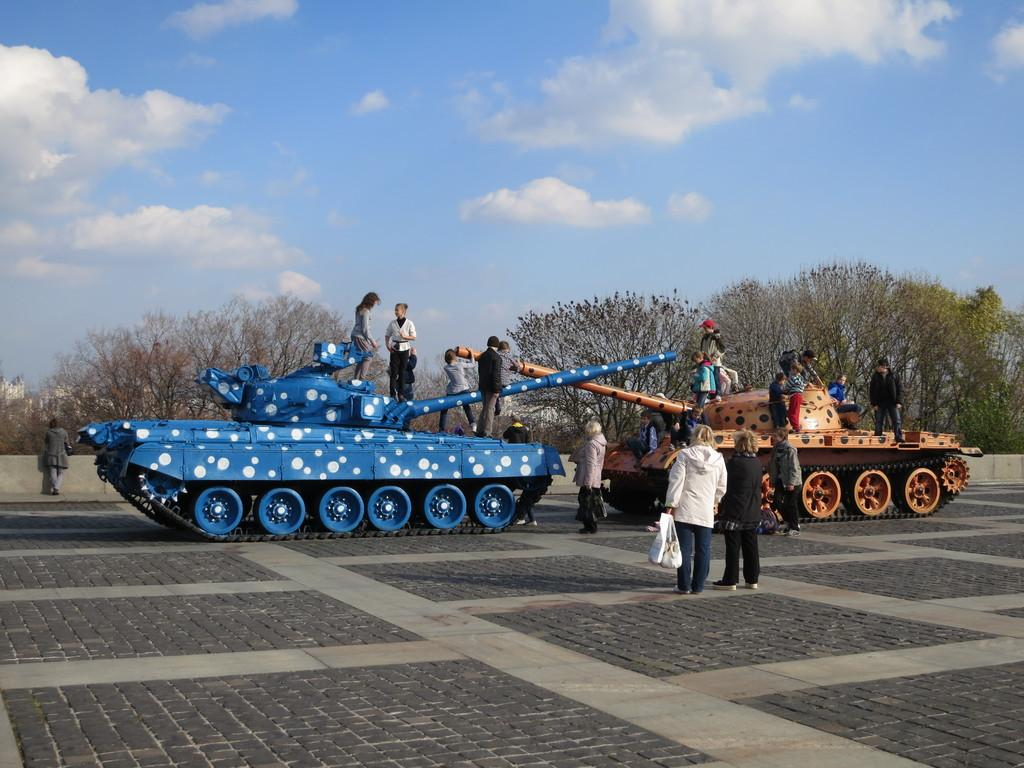What type of vehicles are present in the image? There are two battle tanks in the image. Are there any people in the image? Yes, there are people standing in the image. What type of natural environment can be seen in the image? There are trees visible in the image. What is visible at the top of the image? The sky is visible at the top of the image. How many hats can be seen on the trees in the image? There are no hats visible on the trees in the image. What event is taking place in the image? The provided facts do not mention any specific event taking place in the image. 